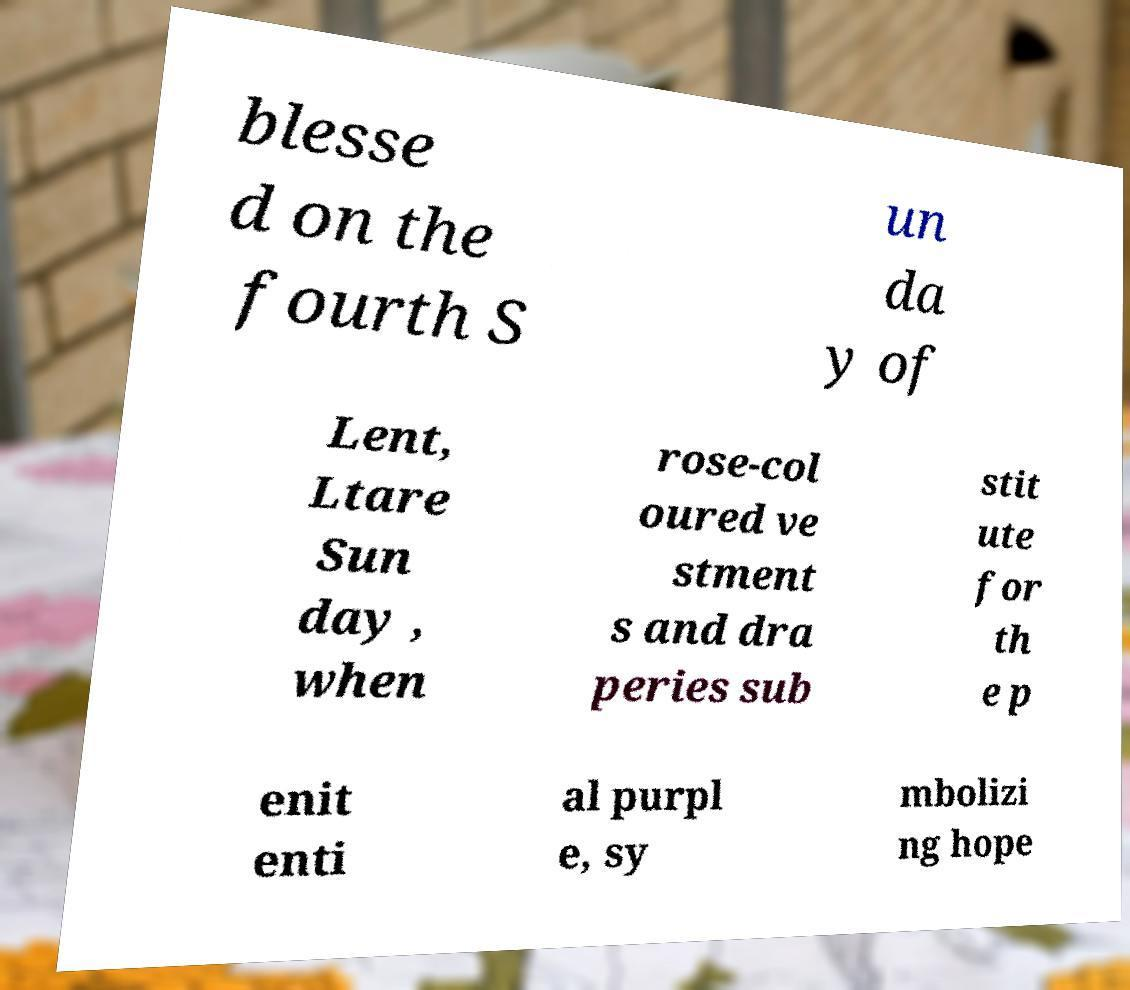What messages or text are displayed in this image? I need them in a readable, typed format. blesse d on the fourth S un da y of Lent, Ltare Sun day , when rose-col oured ve stment s and dra peries sub stit ute for th e p enit enti al purpl e, sy mbolizi ng hope 